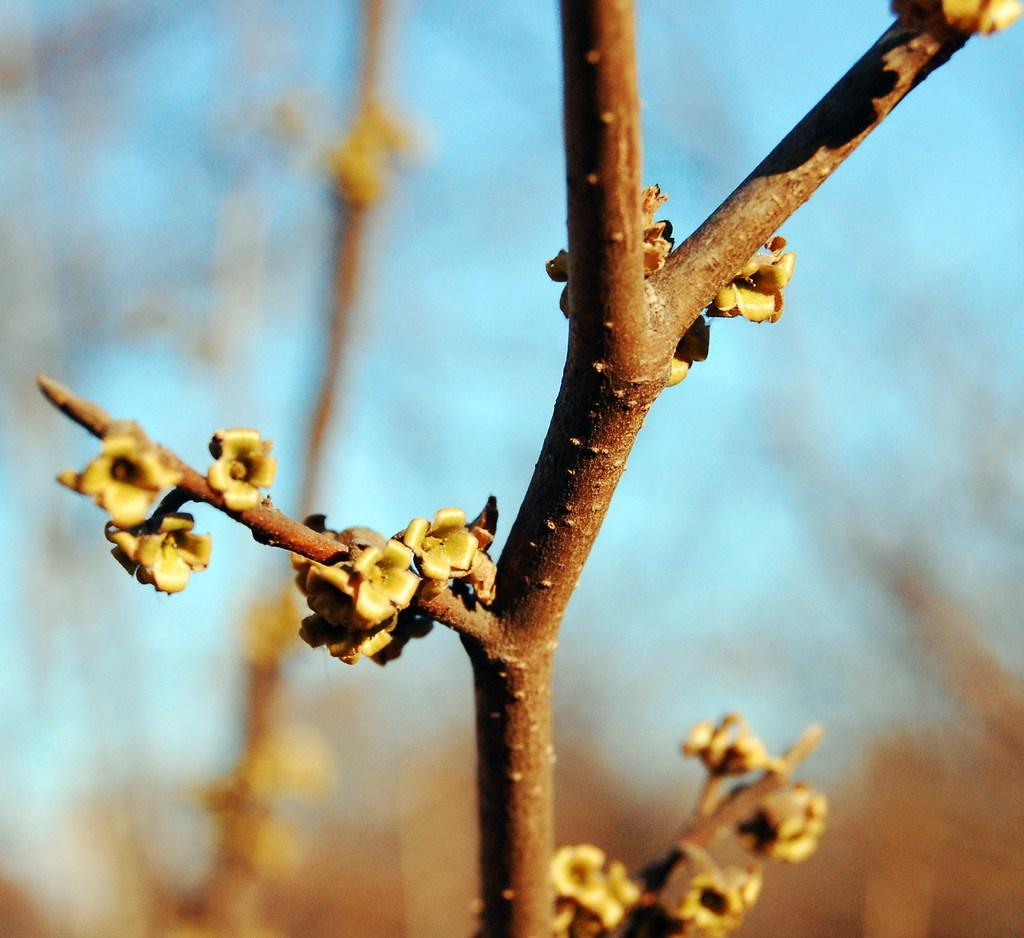What is present in the image that is related to plants? There is a branch and flowers in the image. What color is the sky in the image? The sky is blue in the image. What is the price of the earth in the image? There is no earth present in the image, and therefore no price can be determined. 